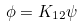<formula> <loc_0><loc_0><loc_500><loc_500>\phi = K _ { 1 2 } \psi</formula> 